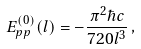<formula> <loc_0><loc_0><loc_500><loc_500>E ^ { ( 0 ) } _ { p p } ( l ) = - \frac { \pi ^ { 2 } \hbar { c } } { 7 2 0 l ^ { 3 } } \, ,</formula> 